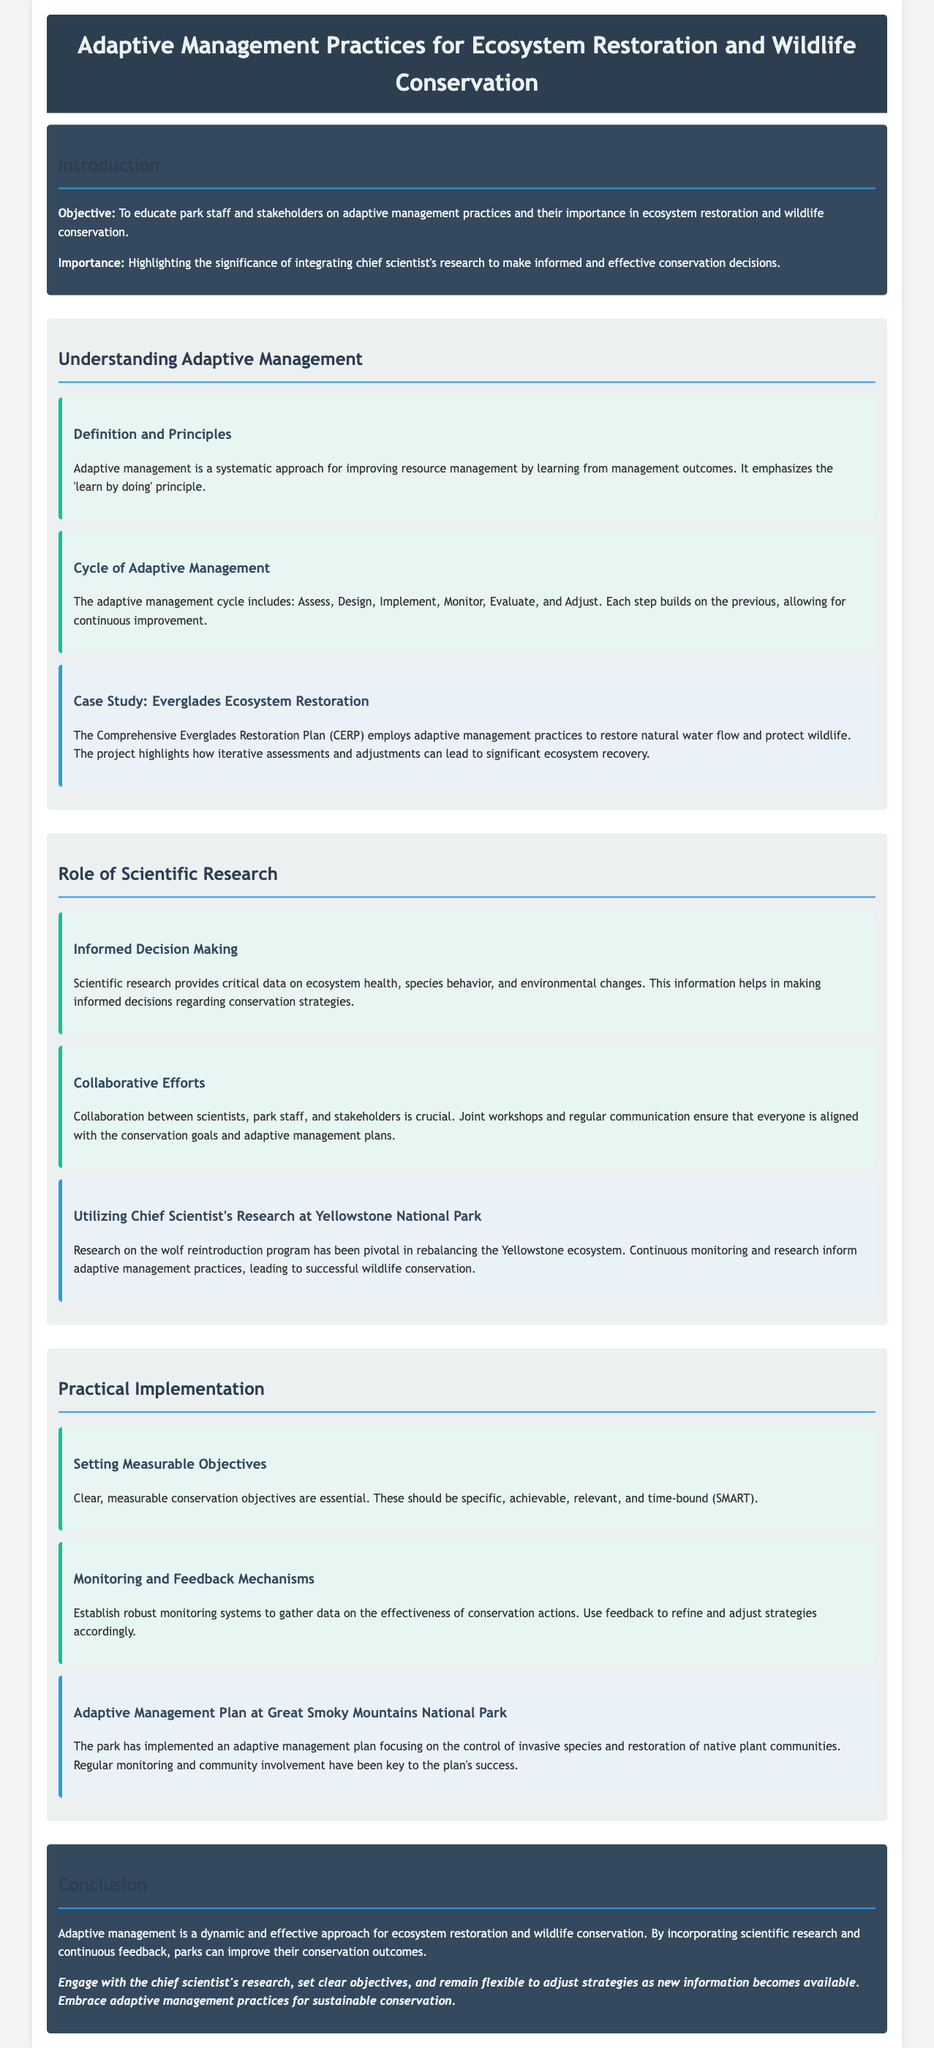what is the objective of the lesson plan? The objective is to educate park staff and stakeholders on adaptive management practices and their importance in ecosystem restoration and wildlife conservation.
Answer: educate park staff and stakeholders what does the adaptive management cycle include? The cycle includes: Assess, Design, Implement, Monitor, Evaluate, and Adjust.
Answer: Assess, Design, Implement, Monitor, Evaluate, Adjust which case study is mentioned in relation to ecosystem restoration? The case study mentioned is the Comprehensive Everglades Restoration Plan (CERP).
Answer: Comprehensive Everglades Restoration Plan what are the key components of informed decision making in conservation? Scientific research provides critical data on ecosystem health, species behavior, and environmental changes.
Answer: critical data what park is highlighted for the utilization of scientific research in adaptive management? The park highlighted is Yellowstone National Park.
Answer: Yellowstone National Park what type of objectives should be set for conservation actions? Objectives should be specific, achievable, relevant, and time-bound (SMART).
Answer: SMART how does Great Smoky Mountains National Park implement its adaptive management plan? The park implements the plan focusing on the control of invasive species and restoration of native plant communities.
Answer: control of invasive species and restoration of native plant communities what is emphasized as a crucial element in collaborative efforts? Collaboration between scientists, park staff, and stakeholders is crucial.
Answer: collaboration what should be engaged to improve conservation outcomes? Engage with the chief scientist's research to improve conservation outcomes.
Answer: chief scientist's research 